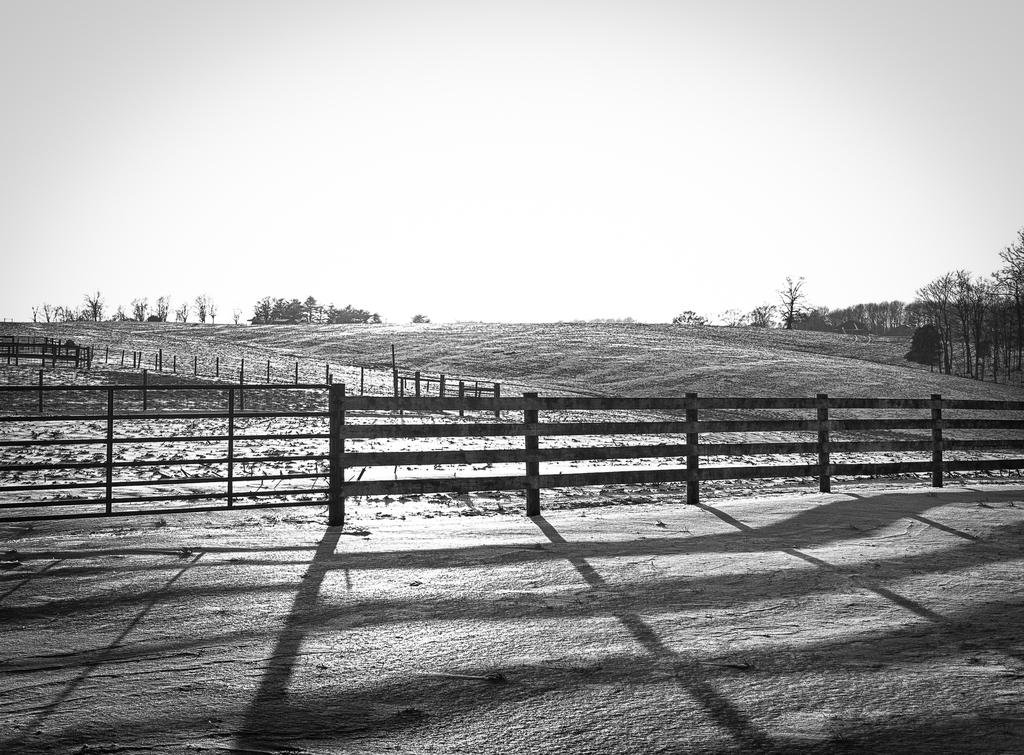What is the color scheme of the image? The image is black and white. What can be seen in the front of the image? There is a railing in the front of the image. What type of natural elements are visible in the background of the image? There are trees and the sky visible in the background of the image. What type of objects can be seen in the background of the image? There are wooden objects in the background of the image. How many cats are sitting on the rock in the image? There are no cats or rocks present in the image. 